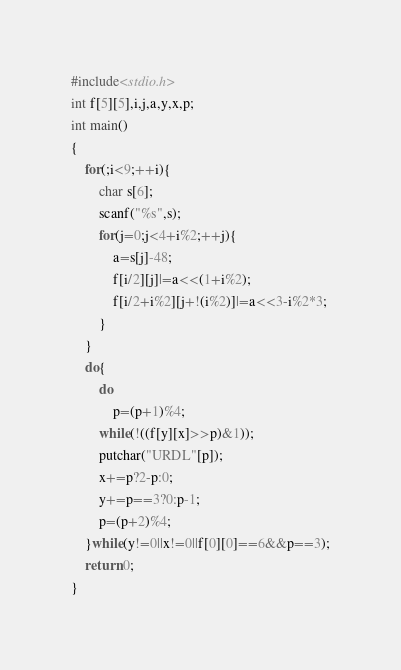Convert code to text. <code><loc_0><loc_0><loc_500><loc_500><_C_>#include<stdio.h>
int f[5][5],i,j,a,y,x,p;
int main()
{
	for(;i<9;++i){
		char s[6];
		scanf("%s",s);
		for(j=0;j<4+i%2;++j){
			a=s[j]-48;
			f[i/2][j]|=a<<(1+i%2);
			f[i/2+i%2][j+!(i%2)]|=a<<3-i%2*3;
		}
	}
	do{
		do
			p=(p+1)%4;
		while(!((f[y][x]>>p)&1));
		putchar("URDL"[p]);
		x+=p?2-p:0;
		y+=p==3?0:p-1;
		p=(p+2)%4;
	}while(y!=0||x!=0||f[0][0]==6&&p==3);
	return 0; 
}</code> 